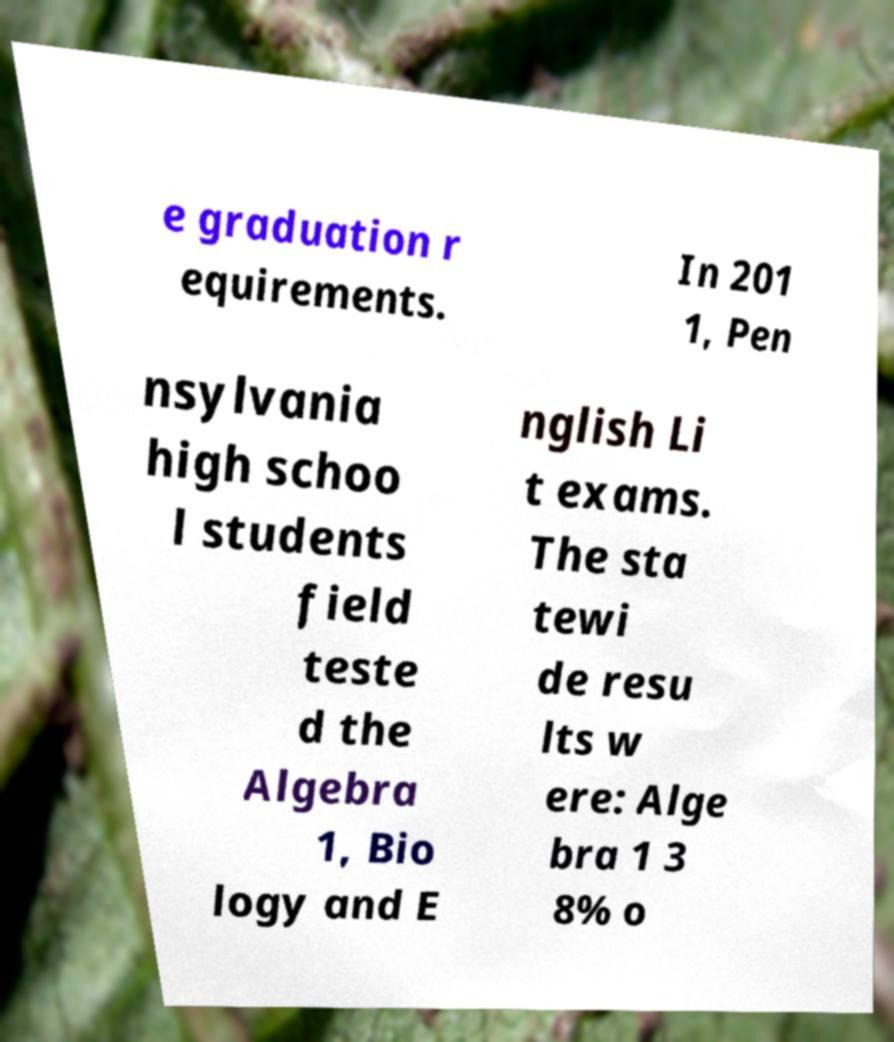Could you extract and type out the text from this image? e graduation r equirements. In 201 1, Pen nsylvania high schoo l students field teste d the Algebra 1, Bio logy and E nglish Li t exams. The sta tewi de resu lts w ere: Alge bra 1 3 8% o 